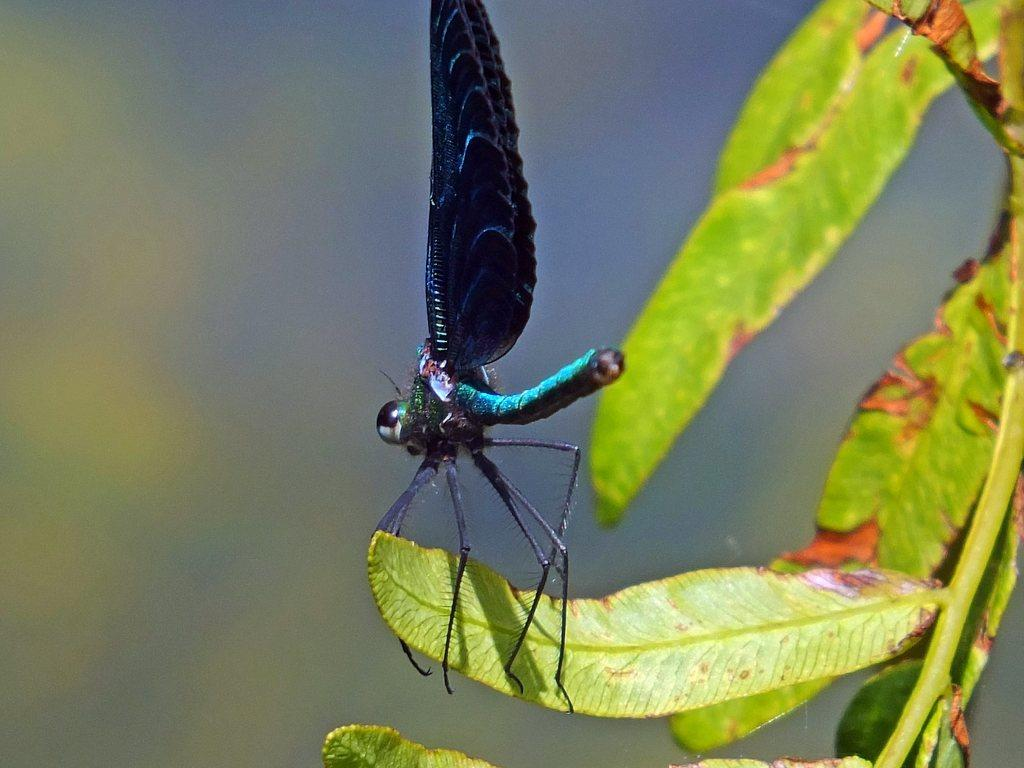What type of vegetation is present in the image? There are green leaves in the image. Can you describe any living organisms on the leaves? Yes, there is an insect on one of the leaves. What can be observed about the background of the image? The background of the image is blurred. What type of milk can be seen being poured in the image? There is no milk present in the image; it features green leaves and an insect. 